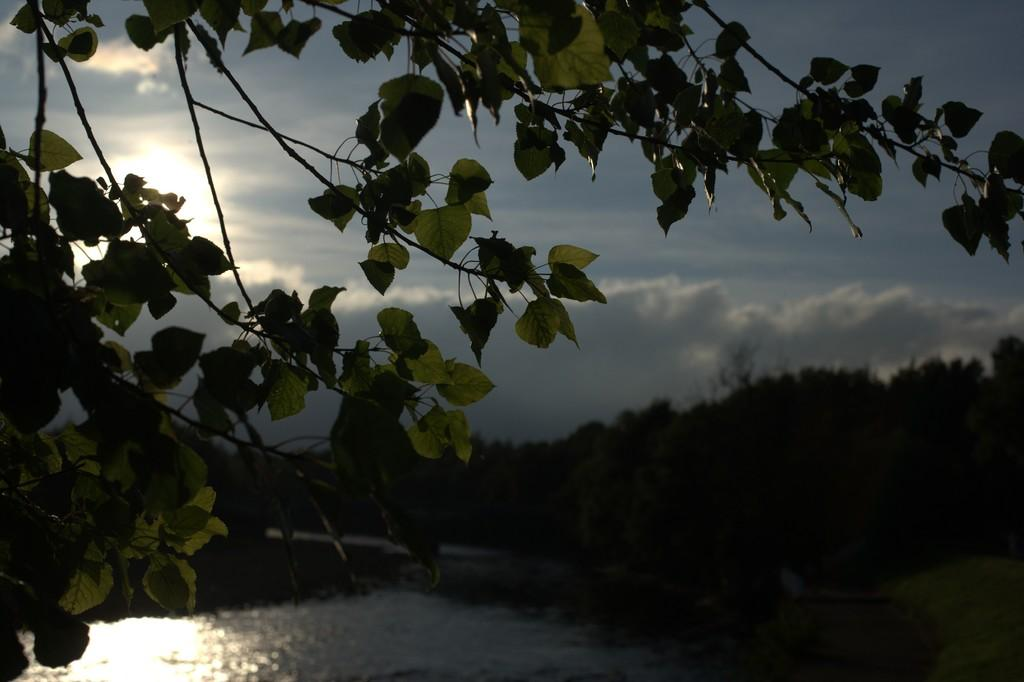What type of vegetation can be seen in the image? There are trees in the image. What natural element is visible in the image besides the trees? There is water visible in the image. What colors can be seen in the sky in the image? The sky is blue and white in color. What type of plane can be seen flying through the water in the image? There is no plane visible in the image; it only features trees, water, and a blue and white sky. 